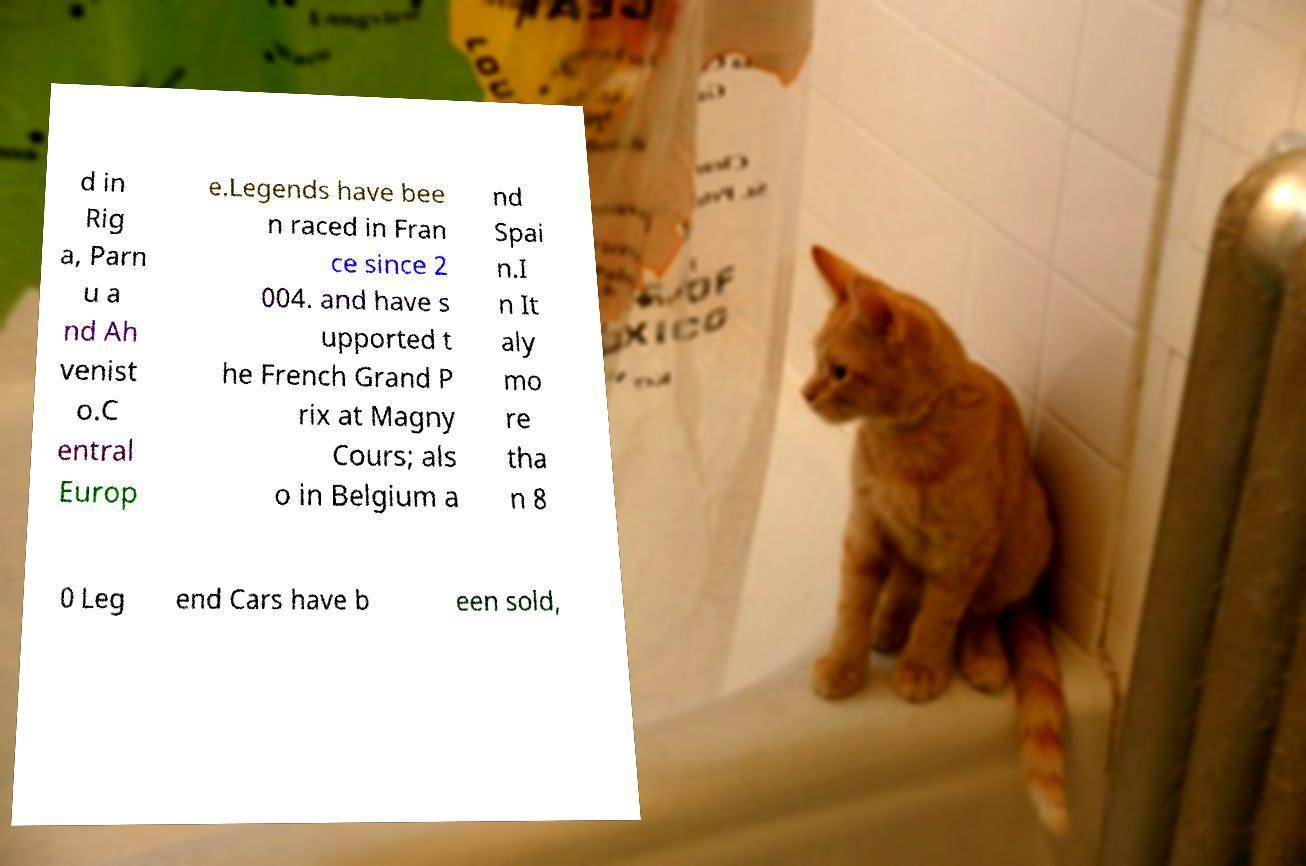Could you extract and type out the text from this image? d in Rig a, Parn u a nd Ah venist o.C entral Europ e.Legends have bee n raced in Fran ce since 2 004. and have s upported t he French Grand P rix at Magny Cours; als o in Belgium a nd Spai n.I n It aly mo re tha n 8 0 Leg end Cars have b een sold, 